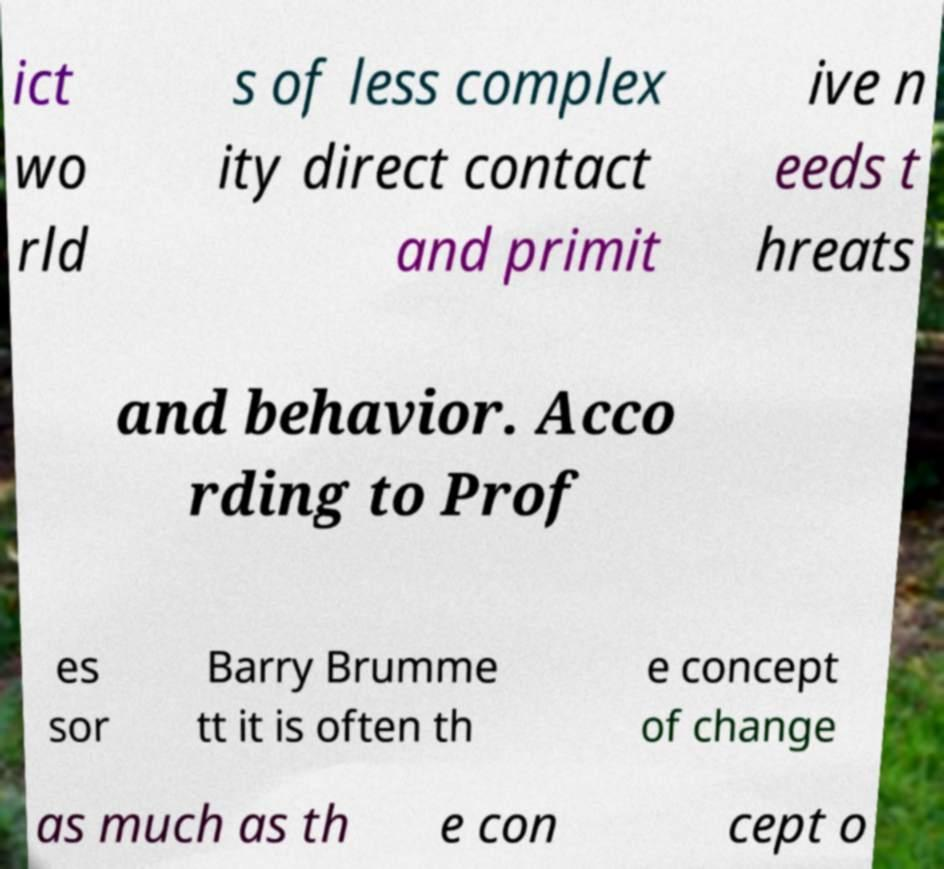For documentation purposes, I need the text within this image transcribed. Could you provide that? ict wo rld s of less complex ity direct contact and primit ive n eeds t hreats and behavior. Acco rding to Prof es sor Barry Brumme tt it is often th e concept of change as much as th e con cept o 